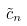<formula> <loc_0><loc_0><loc_500><loc_500>\tilde { c } _ { n }</formula> 